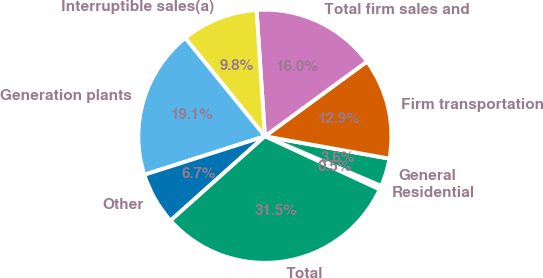Convert chart to OTSL. <chart><loc_0><loc_0><loc_500><loc_500><pie_chart><fcel>Residential<fcel>General<fcel>Firm transportation<fcel>Total firm sales and<fcel>Interruptible sales(a)<fcel>Generation plants<fcel>Other<fcel>Total<nl><fcel>0.49%<fcel>3.59%<fcel>12.89%<fcel>15.99%<fcel>9.79%<fcel>19.08%<fcel>6.69%<fcel>31.48%<nl></chart> 